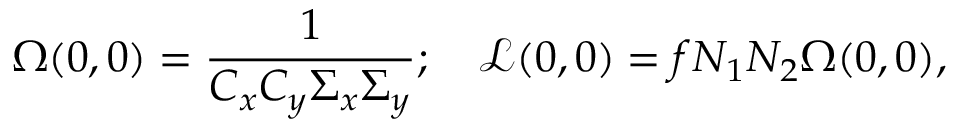<formula> <loc_0><loc_0><loc_500><loc_500>\Omega ( 0 , 0 ) = \frac { 1 } { C _ { x } C _ { y } \Sigma _ { x } \Sigma _ { y } } ; \quad \mathcal { L } ( 0 , 0 ) = f N _ { 1 } N _ { 2 } \Omega ( 0 , 0 ) ,</formula> 